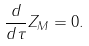Convert formula to latex. <formula><loc_0><loc_0><loc_500><loc_500>\frac { d } { d \tau } Z _ { M } = 0 .</formula> 